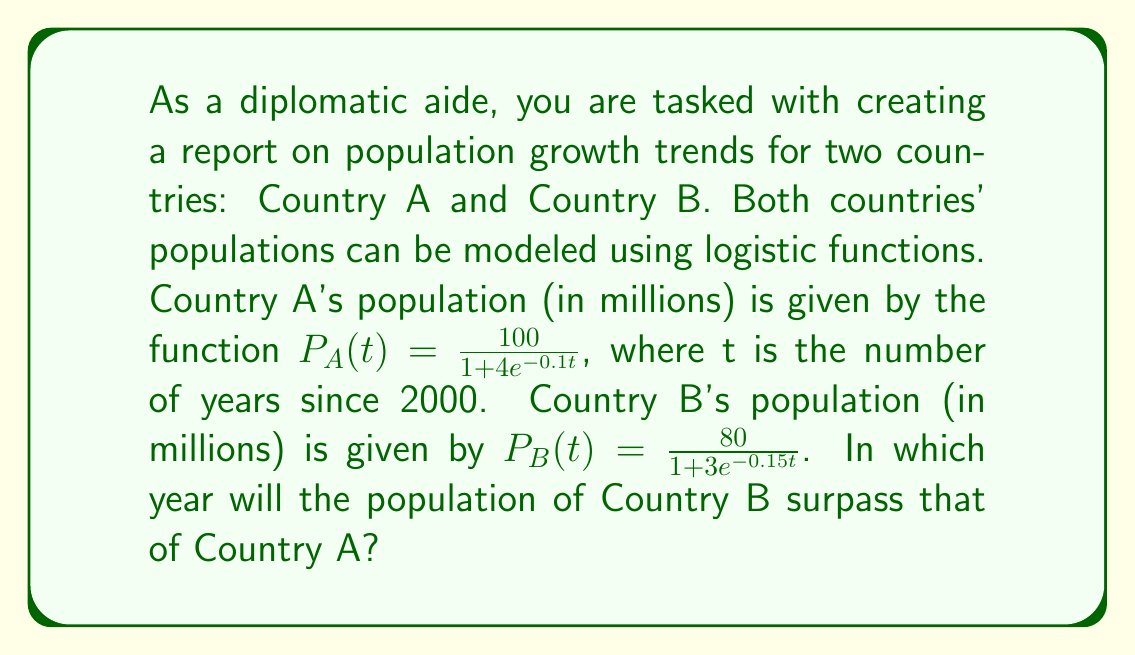Show me your answer to this math problem. To solve this problem, we need to follow these steps:

1) First, we need to set up an equation where the populations of both countries are equal:

   $$\frac{100}{1 + 4e^{-0.1t}} = \frac{80}{1 + 3e^{-0.15t}}$$

2) We can solve this equation for t using the following steps:

   a) Multiply both sides by $(1 + 4e^{-0.1t})(1 + 3e^{-0.15t})$:
      $$100(1 + 3e^{-0.15t}) = 80(1 + 4e^{-0.1t})$$

   b) Expand:
      $$100 + 300e^{-0.15t} = 80 + 320e^{-0.1t}$$

   c) Subtract 80 from both sides:
      $$20 + 300e^{-0.15t} = 320e^{-0.1t}$$

   d) Subtract 20 from both sides:
      $$300e^{-0.15t} = 320e^{-0.1t} - 20$$

   e) Divide both sides by 300:
      $$e^{-0.15t} = \frac{320e^{-0.1t} - 20}{300}$$

3) This equation cannot be solved algebraically. We need to use numerical methods or graphing to find the solution.

4) Using a graphing calculator or computer software, we can find that this equation is satisfied when t ≈ 46.67 years.

5) Since t represents the number of years since 2000, we add 2000 to this value:
   2000 + 46.67 ≈ 2046.67

6) Rounding to the nearest year, we get 2047.

Therefore, the population of Country B will surpass that of Country A in 2047.
Answer: 2047 